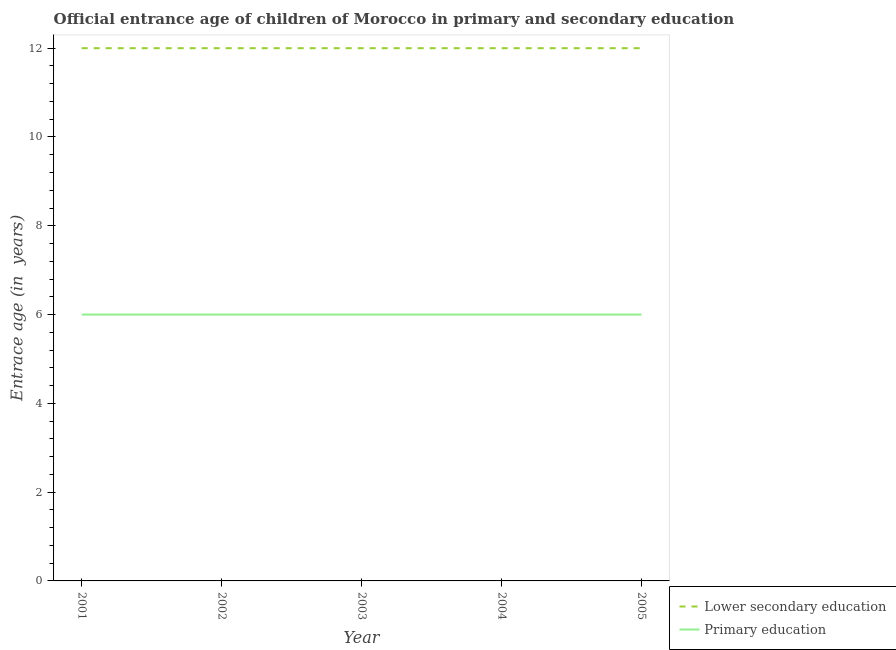How many different coloured lines are there?
Your answer should be compact. 2. Is the number of lines equal to the number of legend labels?
Your answer should be very brief. Yes. What is the entrance age of children in lower secondary education in 2005?
Your answer should be compact. 12. Across all years, what is the maximum entrance age of children in lower secondary education?
Your answer should be very brief. 12. Across all years, what is the minimum entrance age of chiildren in primary education?
Ensure brevity in your answer.  6. In which year was the entrance age of children in lower secondary education maximum?
Provide a succinct answer. 2001. What is the total entrance age of children in lower secondary education in the graph?
Your answer should be compact. 60. What is the difference between the entrance age of children in lower secondary education in 2001 and that in 2005?
Your answer should be compact. 0. What is the difference between the entrance age of children in lower secondary education in 2004 and the entrance age of chiildren in primary education in 2002?
Your answer should be very brief. 6. What is the average entrance age of children in lower secondary education per year?
Offer a terse response. 12. In the year 2001, what is the difference between the entrance age of children in lower secondary education and entrance age of chiildren in primary education?
Your response must be concise. 6. Is the entrance age of chiildren in primary education in 2002 less than that in 2004?
Offer a very short reply. No. Is the difference between the entrance age of children in lower secondary education in 2001 and 2002 greater than the difference between the entrance age of chiildren in primary education in 2001 and 2002?
Your answer should be compact. No. In how many years, is the entrance age of children in lower secondary education greater than the average entrance age of children in lower secondary education taken over all years?
Provide a short and direct response. 0. Does the entrance age of chiildren in primary education monotonically increase over the years?
Your answer should be very brief. No. Is the entrance age of chiildren in primary education strictly greater than the entrance age of children in lower secondary education over the years?
Keep it short and to the point. No. Is the entrance age of children in lower secondary education strictly less than the entrance age of chiildren in primary education over the years?
Your answer should be very brief. No. How many lines are there?
Your answer should be compact. 2. How many years are there in the graph?
Your answer should be compact. 5. What is the difference between two consecutive major ticks on the Y-axis?
Make the answer very short. 2. Does the graph contain any zero values?
Your answer should be compact. No. What is the title of the graph?
Offer a very short reply. Official entrance age of children of Morocco in primary and secondary education. Does "Foreign liabilities" appear as one of the legend labels in the graph?
Give a very brief answer. No. What is the label or title of the Y-axis?
Your answer should be compact. Entrace age (in  years). What is the Entrace age (in  years) of Lower secondary education in 2001?
Offer a terse response. 12. What is the Entrace age (in  years) in Primary education in 2001?
Provide a succinct answer. 6. What is the Entrace age (in  years) in Primary education in 2002?
Offer a terse response. 6. What is the Entrace age (in  years) in Lower secondary education in 2004?
Provide a succinct answer. 12. What is the Entrace age (in  years) of Primary education in 2004?
Offer a very short reply. 6. What is the Entrace age (in  years) of Lower secondary education in 2005?
Offer a very short reply. 12. Across all years, what is the maximum Entrace age (in  years) in Lower secondary education?
Keep it short and to the point. 12. Across all years, what is the maximum Entrace age (in  years) in Primary education?
Your answer should be compact. 6. Across all years, what is the minimum Entrace age (in  years) of Lower secondary education?
Your answer should be compact. 12. What is the difference between the Entrace age (in  years) of Lower secondary education in 2001 and that in 2003?
Make the answer very short. 0. What is the difference between the Entrace age (in  years) in Primary education in 2001 and that in 2005?
Keep it short and to the point. 0. What is the difference between the Entrace age (in  years) in Primary education in 2002 and that in 2003?
Your response must be concise. 0. What is the difference between the Entrace age (in  years) in Lower secondary education in 2002 and that in 2004?
Give a very brief answer. 0. What is the difference between the Entrace age (in  years) in Primary education in 2002 and that in 2004?
Provide a succinct answer. 0. What is the difference between the Entrace age (in  years) of Lower secondary education in 2003 and that in 2004?
Offer a terse response. 0. What is the difference between the Entrace age (in  years) of Lower secondary education in 2001 and the Entrace age (in  years) of Primary education in 2002?
Give a very brief answer. 6. What is the difference between the Entrace age (in  years) in Lower secondary education in 2001 and the Entrace age (in  years) in Primary education in 2005?
Your answer should be compact. 6. What is the difference between the Entrace age (in  years) of Lower secondary education in 2002 and the Entrace age (in  years) of Primary education in 2003?
Offer a terse response. 6. What is the difference between the Entrace age (in  years) in Lower secondary education in 2002 and the Entrace age (in  years) in Primary education in 2004?
Provide a succinct answer. 6. What is the difference between the Entrace age (in  years) of Lower secondary education in 2003 and the Entrace age (in  years) of Primary education in 2004?
Provide a succinct answer. 6. What is the difference between the Entrace age (in  years) in Lower secondary education in 2003 and the Entrace age (in  years) in Primary education in 2005?
Offer a very short reply. 6. What is the difference between the Entrace age (in  years) of Lower secondary education in 2004 and the Entrace age (in  years) of Primary education in 2005?
Provide a succinct answer. 6. What is the average Entrace age (in  years) in Lower secondary education per year?
Offer a very short reply. 12. In the year 2001, what is the difference between the Entrace age (in  years) in Lower secondary education and Entrace age (in  years) in Primary education?
Provide a short and direct response. 6. In the year 2002, what is the difference between the Entrace age (in  years) in Lower secondary education and Entrace age (in  years) in Primary education?
Give a very brief answer. 6. In the year 2003, what is the difference between the Entrace age (in  years) in Lower secondary education and Entrace age (in  years) in Primary education?
Keep it short and to the point. 6. In the year 2004, what is the difference between the Entrace age (in  years) of Lower secondary education and Entrace age (in  years) of Primary education?
Provide a succinct answer. 6. What is the ratio of the Entrace age (in  years) of Lower secondary education in 2001 to that in 2002?
Keep it short and to the point. 1. What is the ratio of the Entrace age (in  years) of Primary education in 2001 to that in 2002?
Provide a short and direct response. 1. What is the ratio of the Entrace age (in  years) of Lower secondary education in 2001 to that in 2003?
Make the answer very short. 1. What is the ratio of the Entrace age (in  years) in Lower secondary education in 2001 to that in 2004?
Make the answer very short. 1. What is the ratio of the Entrace age (in  years) of Primary education in 2001 to that in 2005?
Your answer should be very brief. 1. What is the ratio of the Entrace age (in  years) of Primary education in 2003 to that in 2004?
Keep it short and to the point. 1. What is the ratio of the Entrace age (in  years) in Lower secondary education in 2003 to that in 2005?
Give a very brief answer. 1. What is the ratio of the Entrace age (in  years) in Primary education in 2004 to that in 2005?
Keep it short and to the point. 1. What is the difference between the highest and the lowest Entrace age (in  years) of Lower secondary education?
Give a very brief answer. 0. 